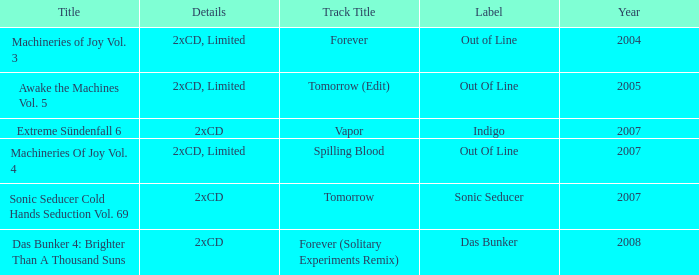Which information is associated with the deviating label and the year 2005? 2xCD, Limited. 